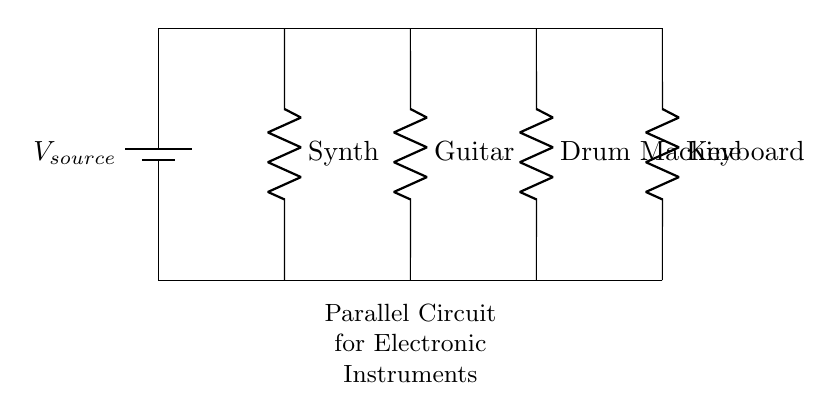What components are in this circuit? The circuit includes a battery, a synthesizer, a guitar, a drum machine, and a keyboard. These are the labeled components that connect parallel to the power supply.
Answer: battery, synthesizer, guitar, drum machine, keyboard What is the role of the battery in this circuit? The battery serves as the voltage source that provides electrical energy to all connected instruments. It is essential for supplying the required voltage.
Answer: voltage source How many instruments can be powered simultaneously? The circuit has four distinct resistors connected in parallel. Each resistor represents an instrument, indicating that four instruments can be powered at once.
Answer: four What happens to the voltage across each instrument? In a parallel circuit, the voltage across each instrument remains the same as the voltage of the source, which is effectively unchanged across all components.
Answer: same as source voltage Which instrument seems to have the highest resistance? The instrument with the greatest resistance is typically the synthesizer, guitar, and drum machine since all are labeled as resistors, but the values are not specified. Reasoning based on typical designs may indicate that synthesizers generally have higher resistance.
Answer: synthesizer What would happen if one instrument is disconnected? If one instrument is disconnected in a parallel circuit, the other instruments would still receive the same voltage and continue to function normally. This is a key characteristic of parallel circuits where each component operates independently.
Answer: others continue to work How does current behave in this circuit? In a parallel circuit, the total current divides among all connected components, but each instrument draws its own current from the source. The total current is the sum of the currents through each instrument.
Answer: divides among components 